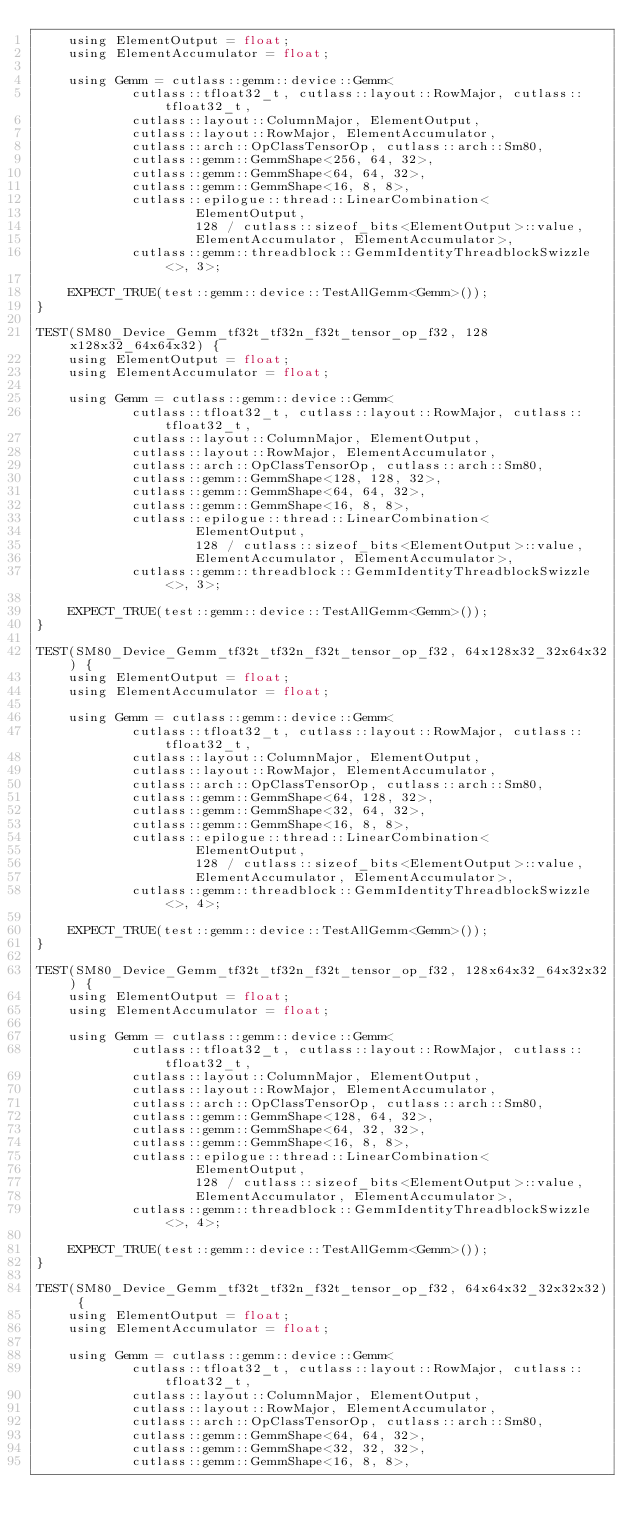Convert code to text. <code><loc_0><loc_0><loc_500><loc_500><_Cuda_>    using ElementOutput = float;
    using ElementAccumulator = float;

    using Gemm = cutlass::gemm::device::Gemm<
            cutlass::tfloat32_t, cutlass::layout::RowMajor, cutlass::tfloat32_t,
            cutlass::layout::ColumnMajor, ElementOutput,
            cutlass::layout::RowMajor, ElementAccumulator,
            cutlass::arch::OpClassTensorOp, cutlass::arch::Sm80,
            cutlass::gemm::GemmShape<256, 64, 32>,
            cutlass::gemm::GemmShape<64, 64, 32>,
            cutlass::gemm::GemmShape<16, 8, 8>,
            cutlass::epilogue::thread::LinearCombination<
                    ElementOutput,
                    128 / cutlass::sizeof_bits<ElementOutput>::value,
                    ElementAccumulator, ElementAccumulator>,
            cutlass::gemm::threadblock::GemmIdentityThreadblockSwizzle<>, 3>;

    EXPECT_TRUE(test::gemm::device::TestAllGemm<Gemm>());
}

TEST(SM80_Device_Gemm_tf32t_tf32n_f32t_tensor_op_f32, 128x128x32_64x64x32) {
    using ElementOutput = float;
    using ElementAccumulator = float;

    using Gemm = cutlass::gemm::device::Gemm<
            cutlass::tfloat32_t, cutlass::layout::RowMajor, cutlass::tfloat32_t,
            cutlass::layout::ColumnMajor, ElementOutput,
            cutlass::layout::RowMajor, ElementAccumulator,
            cutlass::arch::OpClassTensorOp, cutlass::arch::Sm80,
            cutlass::gemm::GemmShape<128, 128, 32>,
            cutlass::gemm::GemmShape<64, 64, 32>,
            cutlass::gemm::GemmShape<16, 8, 8>,
            cutlass::epilogue::thread::LinearCombination<
                    ElementOutput,
                    128 / cutlass::sizeof_bits<ElementOutput>::value,
                    ElementAccumulator, ElementAccumulator>,
            cutlass::gemm::threadblock::GemmIdentityThreadblockSwizzle<>, 3>;

    EXPECT_TRUE(test::gemm::device::TestAllGemm<Gemm>());
}

TEST(SM80_Device_Gemm_tf32t_tf32n_f32t_tensor_op_f32, 64x128x32_32x64x32) {
    using ElementOutput = float;
    using ElementAccumulator = float;

    using Gemm = cutlass::gemm::device::Gemm<
            cutlass::tfloat32_t, cutlass::layout::RowMajor, cutlass::tfloat32_t,
            cutlass::layout::ColumnMajor, ElementOutput,
            cutlass::layout::RowMajor, ElementAccumulator,
            cutlass::arch::OpClassTensorOp, cutlass::arch::Sm80,
            cutlass::gemm::GemmShape<64, 128, 32>,
            cutlass::gemm::GemmShape<32, 64, 32>,
            cutlass::gemm::GemmShape<16, 8, 8>,
            cutlass::epilogue::thread::LinearCombination<
                    ElementOutput,
                    128 / cutlass::sizeof_bits<ElementOutput>::value,
                    ElementAccumulator, ElementAccumulator>,
            cutlass::gemm::threadblock::GemmIdentityThreadblockSwizzle<>, 4>;

    EXPECT_TRUE(test::gemm::device::TestAllGemm<Gemm>());
}

TEST(SM80_Device_Gemm_tf32t_tf32n_f32t_tensor_op_f32, 128x64x32_64x32x32) {
    using ElementOutput = float;
    using ElementAccumulator = float;

    using Gemm = cutlass::gemm::device::Gemm<
            cutlass::tfloat32_t, cutlass::layout::RowMajor, cutlass::tfloat32_t,
            cutlass::layout::ColumnMajor, ElementOutput,
            cutlass::layout::RowMajor, ElementAccumulator,
            cutlass::arch::OpClassTensorOp, cutlass::arch::Sm80,
            cutlass::gemm::GemmShape<128, 64, 32>,
            cutlass::gemm::GemmShape<64, 32, 32>,
            cutlass::gemm::GemmShape<16, 8, 8>,
            cutlass::epilogue::thread::LinearCombination<
                    ElementOutput,
                    128 / cutlass::sizeof_bits<ElementOutput>::value,
                    ElementAccumulator, ElementAccumulator>,
            cutlass::gemm::threadblock::GemmIdentityThreadblockSwizzle<>, 4>;

    EXPECT_TRUE(test::gemm::device::TestAllGemm<Gemm>());
}

TEST(SM80_Device_Gemm_tf32t_tf32n_f32t_tensor_op_f32, 64x64x32_32x32x32) {
    using ElementOutput = float;
    using ElementAccumulator = float;

    using Gemm = cutlass::gemm::device::Gemm<
            cutlass::tfloat32_t, cutlass::layout::RowMajor, cutlass::tfloat32_t,
            cutlass::layout::ColumnMajor, ElementOutput,
            cutlass::layout::RowMajor, ElementAccumulator,
            cutlass::arch::OpClassTensorOp, cutlass::arch::Sm80,
            cutlass::gemm::GemmShape<64, 64, 32>,
            cutlass::gemm::GemmShape<32, 32, 32>,
            cutlass::gemm::GemmShape<16, 8, 8>,</code> 